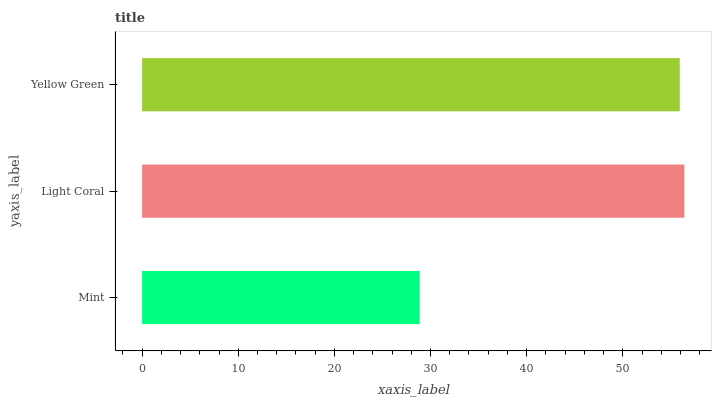Is Mint the minimum?
Answer yes or no. Yes. Is Light Coral the maximum?
Answer yes or no. Yes. Is Yellow Green the minimum?
Answer yes or no. No. Is Yellow Green the maximum?
Answer yes or no. No. Is Light Coral greater than Yellow Green?
Answer yes or no. Yes. Is Yellow Green less than Light Coral?
Answer yes or no. Yes. Is Yellow Green greater than Light Coral?
Answer yes or no. No. Is Light Coral less than Yellow Green?
Answer yes or no. No. Is Yellow Green the high median?
Answer yes or no. Yes. Is Yellow Green the low median?
Answer yes or no. Yes. Is Light Coral the high median?
Answer yes or no. No. Is Mint the low median?
Answer yes or no. No. 